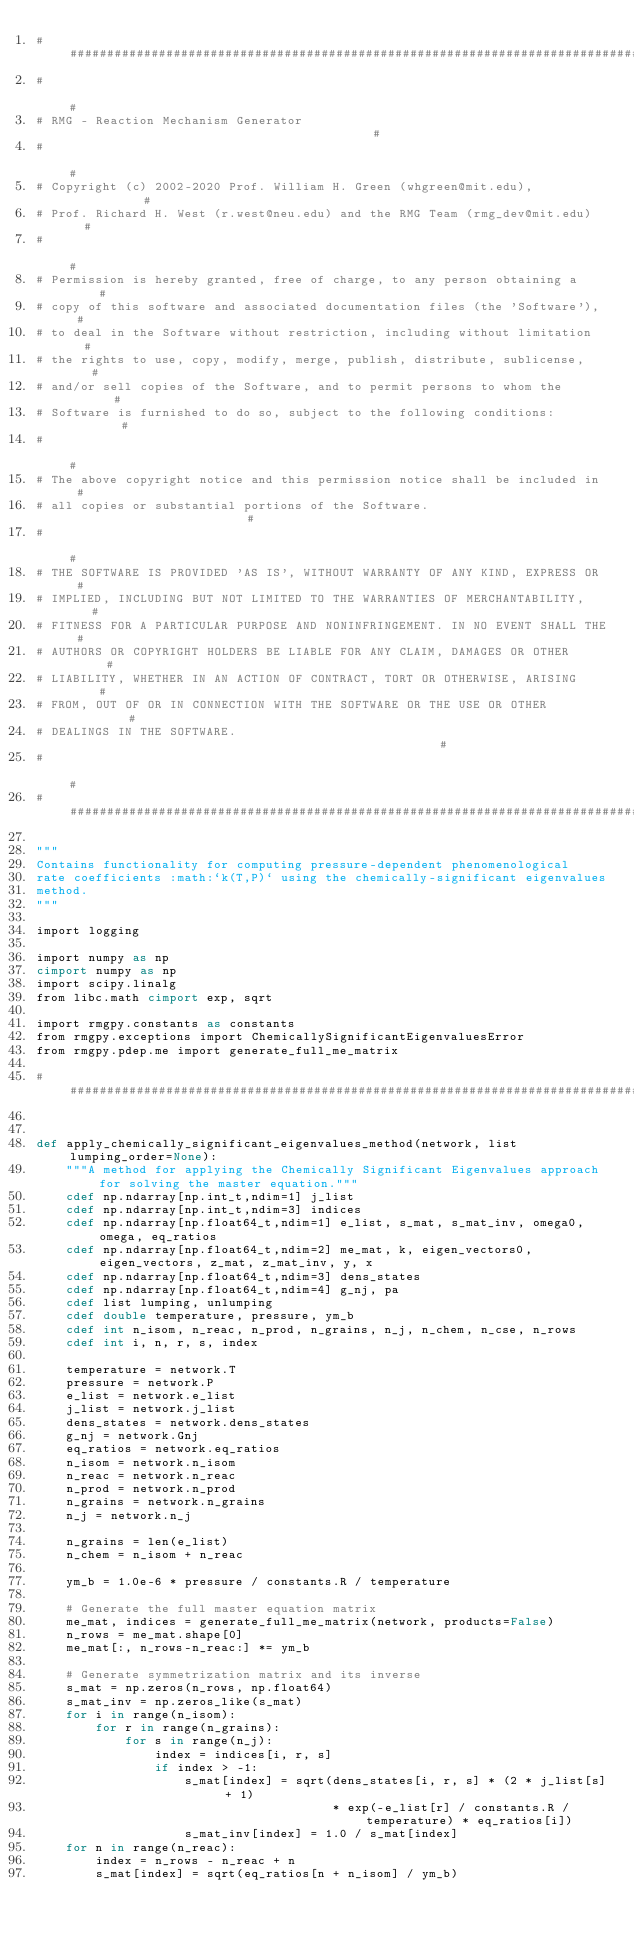Convert code to text. <code><loc_0><loc_0><loc_500><loc_500><_Cython_>###############################################################################
#                                                                             #
# RMG - Reaction Mechanism Generator                                          #
#                                                                             #
# Copyright (c) 2002-2020 Prof. William H. Green (whgreen@mit.edu),           #
# Prof. Richard H. West (r.west@neu.edu) and the RMG Team (rmg_dev@mit.edu)   #
#                                                                             #
# Permission is hereby granted, free of charge, to any person obtaining a     #
# copy of this software and associated documentation files (the 'Software'),  #
# to deal in the Software without restriction, including without limitation   #
# the rights to use, copy, modify, merge, publish, distribute, sublicense,    #
# and/or sell copies of the Software, and to permit persons to whom the       #
# Software is furnished to do so, subject to the following conditions:        #
#                                                                             #
# The above copyright notice and this permission notice shall be included in  #
# all copies or substantial portions of the Software.                         #
#                                                                             #
# THE SOFTWARE IS PROVIDED 'AS IS', WITHOUT WARRANTY OF ANY KIND, EXPRESS OR  #
# IMPLIED, INCLUDING BUT NOT LIMITED TO THE WARRANTIES OF MERCHANTABILITY,    #
# FITNESS FOR A PARTICULAR PURPOSE AND NONINFRINGEMENT. IN NO EVENT SHALL THE #
# AUTHORS OR COPYRIGHT HOLDERS BE LIABLE FOR ANY CLAIM, DAMAGES OR OTHER      #
# LIABILITY, WHETHER IN AN ACTION OF CONTRACT, TORT OR OTHERWISE, ARISING     #
# FROM, OUT OF OR IN CONNECTION WITH THE SOFTWARE OR THE USE OR OTHER         #
# DEALINGS IN THE SOFTWARE.                                                   #
#                                                                             #
###############################################################################

"""
Contains functionality for computing pressure-dependent phenomenological
rate coefficients :math:`k(T,P)` using the chemically-significant eigenvalues
method.
"""

import logging

import numpy as np
cimport numpy as np
import scipy.linalg
from libc.math cimport exp, sqrt

import rmgpy.constants as constants
from rmgpy.exceptions import ChemicallySignificantEigenvaluesError
from rmgpy.pdep.me import generate_full_me_matrix

################################################################################


def apply_chemically_significant_eigenvalues_method(network, list lumping_order=None):
    """A method for applying the Chemically Significant Eigenvalues approach for solving the master equation."""
    cdef np.ndarray[np.int_t,ndim=1] j_list
    cdef np.ndarray[np.int_t,ndim=3] indices
    cdef np.ndarray[np.float64_t,ndim=1] e_list, s_mat, s_mat_inv, omega0, omega, eq_ratios
    cdef np.ndarray[np.float64_t,ndim=2] me_mat, k, eigen_vectors0, eigen_vectors, z_mat, z_mat_inv, y, x
    cdef np.ndarray[np.float64_t,ndim=3] dens_states
    cdef np.ndarray[np.float64_t,ndim=4] g_nj, pa
    cdef list lumping, unlumping
    cdef double temperature, pressure, ym_b
    cdef int n_isom, n_reac, n_prod, n_grains, n_j, n_chem, n_cse, n_rows
    cdef int i, n, r, s, index

    temperature = network.T
    pressure = network.P
    e_list = network.e_list
    j_list = network.j_list
    dens_states = network.dens_states
    g_nj = network.Gnj
    eq_ratios = network.eq_ratios
    n_isom = network.n_isom
    n_reac = network.n_reac
    n_prod = network.n_prod
    n_grains = network.n_grains
    n_j = network.n_j
    
    n_grains = len(e_list)
    n_chem = n_isom + n_reac
    
    ym_b = 1.0e-6 * pressure / constants.R / temperature
    
    # Generate the full master equation matrix
    me_mat, indices = generate_full_me_matrix(network, products=False)
    n_rows = me_mat.shape[0]
    me_mat[:, n_rows-n_reac:] *= ym_b
    
    # Generate symmetrization matrix and its inverse
    s_mat = np.zeros(n_rows, np.float64)
    s_mat_inv = np.zeros_like(s_mat)
    for i in range(n_isom):
        for r in range(n_grains):
            for s in range(n_j):
                index = indices[i, r, s]
                if index > -1:
                    s_mat[index] = sqrt(dens_states[i, r, s] * (2 * j_list[s] + 1)
                                        * exp(-e_list[r] / constants.R / temperature) * eq_ratios[i])
                    s_mat_inv[index] = 1.0 / s_mat[index]
    for n in range(n_reac):
        index = n_rows - n_reac + n
        s_mat[index] = sqrt(eq_ratios[n + n_isom] / ym_b)</code> 